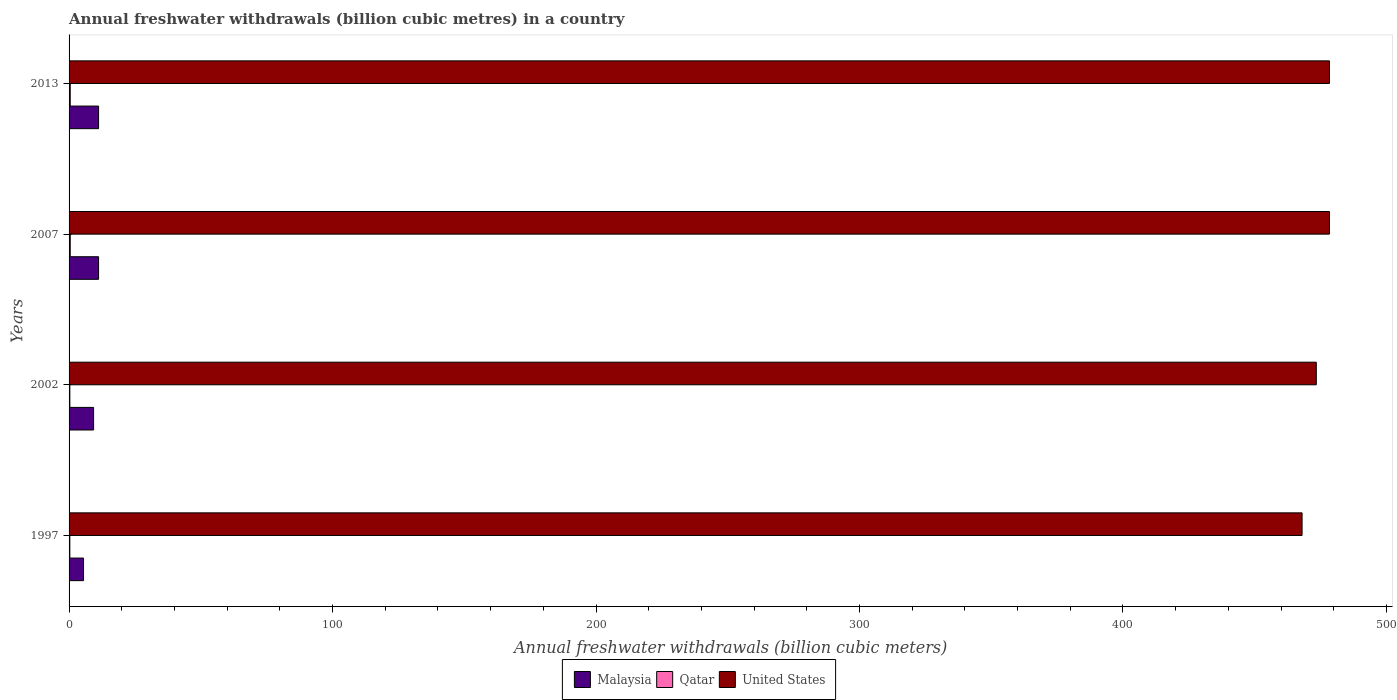How many groups of bars are there?
Offer a terse response. 4. Are the number of bars on each tick of the Y-axis equal?
Give a very brief answer. Yes. How many bars are there on the 4th tick from the top?
Provide a short and direct response. 3. In how many cases, is the number of bars for a given year not equal to the number of legend labels?
Make the answer very short. 0. Across all years, what is the minimum annual freshwater withdrawals in Malaysia?
Provide a succinct answer. 5.49. In which year was the annual freshwater withdrawals in Qatar minimum?
Make the answer very short. 1997. What is the total annual freshwater withdrawals in Qatar in the graph?
Your answer should be very brief. 1.47. What is the difference between the annual freshwater withdrawals in United States in 1997 and that in 2013?
Offer a very short reply. -10.4. What is the difference between the annual freshwater withdrawals in United States in 2007 and the annual freshwater withdrawals in Malaysia in 2002?
Keep it short and to the point. 469.09. What is the average annual freshwater withdrawals in Qatar per year?
Your answer should be compact. 0.37. In the year 2002, what is the difference between the annual freshwater withdrawals in Qatar and annual freshwater withdrawals in United States?
Keep it short and to the point. -473.11. In how many years, is the annual freshwater withdrawals in Malaysia greater than 200 billion cubic meters?
Give a very brief answer. 0. What is the ratio of the annual freshwater withdrawals in Qatar in 2002 to that in 2007?
Keep it short and to the point. 0.66. Is the annual freshwater withdrawals in Qatar in 1997 less than that in 2007?
Your response must be concise. Yes. What is the difference between the highest and the lowest annual freshwater withdrawals in Malaysia?
Offer a terse response. 5.71. In how many years, is the annual freshwater withdrawals in Malaysia greater than the average annual freshwater withdrawals in Malaysia taken over all years?
Offer a very short reply. 3. Is the sum of the annual freshwater withdrawals in United States in 1997 and 2002 greater than the maximum annual freshwater withdrawals in Malaysia across all years?
Provide a succinct answer. Yes. What does the 3rd bar from the top in 1997 represents?
Offer a very short reply. Malaysia. What does the 3rd bar from the bottom in 2013 represents?
Give a very brief answer. United States. How many bars are there?
Provide a succinct answer. 12. Are all the bars in the graph horizontal?
Provide a short and direct response. Yes. What is the difference between two consecutive major ticks on the X-axis?
Offer a terse response. 100. Are the values on the major ticks of X-axis written in scientific E-notation?
Your response must be concise. No. Does the graph contain any zero values?
Keep it short and to the point. No. How are the legend labels stacked?
Provide a short and direct response. Horizontal. What is the title of the graph?
Offer a terse response. Annual freshwater withdrawals (billion cubic metres) in a country. Does "Germany" appear as one of the legend labels in the graph?
Your response must be concise. No. What is the label or title of the X-axis?
Offer a very short reply. Annual freshwater withdrawals (billion cubic meters). What is the label or title of the Y-axis?
Make the answer very short. Years. What is the Annual freshwater withdrawals (billion cubic meters) of Malaysia in 1997?
Your answer should be very brief. 5.49. What is the Annual freshwater withdrawals (billion cubic meters) in Qatar in 1997?
Your answer should be very brief. 0.28. What is the Annual freshwater withdrawals (billion cubic meters) in United States in 1997?
Make the answer very short. 468. What is the Annual freshwater withdrawals (billion cubic meters) in Malaysia in 2002?
Keep it short and to the point. 9.3. What is the Annual freshwater withdrawals (billion cubic meters) in Qatar in 2002?
Offer a terse response. 0.29. What is the Annual freshwater withdrawals (billion cubic meters) in United States in 2002?
Provide a succinct answer. 473.4. What is the Annual freshwater withdrawals (billion cubic meters) in Malaysia in 2007?
Provide a short and direct response. 11.2. What is the Annual freshwater withdrawals (billion cubic meters) in Qatar in 2007?
Your response must be concise. 0.44. What is the Annual freshwater withdrawals (billion cubic meters) in United States in 2007?
Provide a short and direct response. 478.4. What is the Annual freshwater withdrawals (billion cubic meters) of Qatar in 2013?
Keep it short and to the point. 0.44. What is the Annual freshwater withdrawals (billion cubic meters) in United States in 2013?
Offer a terse response. 478.4. Across all years, what is the maximum Annual freshwater withdrawals (billion cubic meters) in Malaysia?
Keep it short and to the point. 11.2. Across all years, what is the maximum Annual freshwater withdrawals (billion cubic meters) of Qatar?
Your answer should be compact. 0.44. Across all years, what is the maximum Annual freshwater withdrawals (billion cubic meters) of United States?
Your answer should be compact. 478.4. Across all years, what is the minimum Annual freshwater withdrawals (billion cubic meters) in Malaysia?
Provide a succinct answer. 5.49. Across all years, what is the minimum Annual freshwater withdrawals (billion cubic meters) in Qatar?
Provide a succinct answer. 0.28. Across all years, what is the minimum Annual freshwater withdrawals (billion cubic meters) of United States?
Keep it short and to the point. 468. What is the total Annual freshwater withdrawals (billion cubic meters) in Malaysia in the graph?
Provide a short and direct response. 37.19. What is the total Annual freshwater withdrawals (billion cubic meters) of Qatar in the graph?
Offer a terse response. 1.47. What is the total Annual freshwater withdrawals (billion cubic meters) of United States in the graph?
Keep it short and to the point. 1898.2. What is the difference between the Annual freshwater withdrawals (billion cubic meters) in Malaysia in 1997 and that in 2002?
Provide a short and direct response. -3.82. What is the difference between the Annual freshwater withdrawals (billion cubic meters) in Qatar in 1997 and that in 2002?
Make the answer very short. -0.01. What is the difference between the Annual freshwater withdrawals (billion cubic meters) in Malaysia in 1997 and that in 2007?
Give a very brief answer. -5.71. What is the difference between the Annual freshwater withdrawals (billion cubic meters) in Qatar in 1997 and that in 2007?
Provide a short and direct response. -0.16. What is the difference between the Annual freshwater withdrawals (billion cubic meters) of Malaysia in 1997 and that in 2013?
Offer a terse response. -5.71. What is the difference between the Annual freshwater withdrawals (billion cubic meters) of Qatar in 1997 and that in 2013?
Make the answer very short. -0.16. What is the difference between the Annual freshwater withdrawals (billion cubic meters) of United States in 1997 and that in 2013?
Your response must be concise. -10.4. What is the difference between the Annual freshwater withdrawals (billion cubic meters) of Malaysia in 2002 and that in 2007?
Make the answer very short. -1.9. What is the difference between the Annual freshwater withdrawals (billion cubic meters) in Qatar in 2002 and that in 2007?
Make the answer very short. -0.15. What is the difference between the Annual freshwater withdrawals (billion cubic meters) of United States in 2002 and that in 2007?
Offer a terse response. -5. What is the difference between the Annual freshwater withdrawals (billion cubic meters) of Malaysia in 2002 and that in 2013?
Provide a succinct answer. -1.9. What is the difference between the Annual freshwater withdrawals (billion cubic meters) in Qatar in 2002 and that in 2013?
Ensure brevity in your answer.  -0.15. What is the difference between the Annual freshwater withdrawals (billion cubic meters) of Malaysia in 1997 and the Annual freshwater withdrawals (billion cubic meters) of Qatar in 2002?
Your response must be concise. 5.19. What is the difference between the Annual freshwater withdrawals (billion cubic meters) in Malaysia in 1997 and the Annual freshwater withdrawals (billion cubic meters) in United States in 2002?
Provide a succinct answer. -467.91. What is the difference between the Annual freshwater withdrawals (billion cubic meters) of Qatar in 1997 and the Annual freshwater withdrawals (billion cubic meters) of United States in 2002?
Provide a short and direct response. -473.12. What is the difference between the Annual freshwater withdrawals (billion cubic meters) in Malaysia in 1997 and the Annual freshwater withdrawals (billion cubic meters) in Qatar in 2007?
Ensure brevity in your answer.  5.04. What is the difference between the Annual freshwater withdrawals (billion cubic meters) in Malaysia in 1997 and the Annual freshwater withdrawals (billion cubic meters) in United States in 2007?
Offer a very short reply. -472.91. What is the difference between the Annual freshwater withdrawals (billion cubic meters) of Qatar in 1997 and the Annual freshwater withdrawals (billion cubic meters) of United States in 2007?
Your response must be concise. -478.12. What is the difference between the Annual freshwater withdrawals (billion cubic meters) of Malaysia in 1997 and the Annual freshwater withdrawals (billion cubic meters) of Qatar in 2013?
Give a very brief answer. 5.04. What is the difference between the Annual freshwater withdrawals (billion cubic meters) in Malaysia in 1997 and the Annual freshwater withdrawals (billion cubic meters) in United States in 2013?
Your answer should be compact. -472.91. What is the difference between the Annual freshwater withdrawals (billion cubic meters) in Qatar in 1997 and the Annual freshwater withdrawals (billion cubic meters) in United States in 2013?
Your answer should be compact. -478.12. What is the difference between the Annual freshwater withdrawals (billion cubic meters) in Malaysia in 2002 and the Annual freshwater withdrawals (billion cubic meters) in Qatar in 2007?
Offer a terse response. 8.86. What is the difference between the Annual freshwater withdrawals (billion cubic meters) of Malaysia in 2002 and the Annual freshwater withdrawals (billion cubic meters) of United States in 2007?
Your answer should be compact. -469.1. What is the difference between the Annual freshwater withdrawals (billion cubic meters) of Qatar in 2002 and the Annual freshwater withdrawals (billion cubic meters) of United States in 2007?
Your answer should be compact. -478.11. What is the difference between the Annual freshwater withdrawals (billion cubic meters) of Malaysia in 2002 and the Annual freshwater withdrawals (billion cubic meters) of Qatar in 2013?
Offer a terse response. 8.86. What is the difference between the Annual freshwater withdrawals (billion cubic meters) of Malaysia in 2002 and the Annual freshwater withdrawals (billion cubic meters) of United States in 2013?
Offer a very short reply. -469.1. What is the difference between the Annual freshwater withdrawals (billion cubic meters) of Qatar in 2002 and the Annual freshwater withdrawals (billion cubic meters) of United States in 2013?
Make the answer very short. -478.11. What is the difference between the Annual freshwater withdrawals (billion cubic meters) of Malaysia in 2007 and the Annual freshwater withdrawals (billion cubic meters) of Qatar in 2013?
Offer a terse response. 10.76. What is the difference between the Annual freshwater withdrawals (billion cubic meters) of Malaysia in 2007 and the Annual freshwater withdrawals (billion cubic meters) of United States in 2013?
Your response must be concise. -467.2. What is the difference between the Annual freshwater withdrawals (billion cubic meters) in Qatar in 2007 and the Annual freshwater withdrawals (billion cubic meters) in United States in 2013?
Give a very brief answer. -477.96. What is the average Annual freshwater withdrawals (billion cubic meters) in Malaysia per year?
Provide a short and direct response. 9.3. What is the average Annual freshwater withdrawals (billion cubic meters) in Qatar per year?
Ensure brevity in your answer.  0.37. What is the average Annual freshwater withdrawals (billion cubic meters) in United States per year?
Give a very brief answer. 474.55. In the year 1997, what is the difference between the Annual freshwater withdrawals (billion cubic meters) of Malaysia and Annual freshwater withdrawals (billion cubic meters) of Qatar?
Your answer should be compact. 5.2. In the year 1997, what is the difference between the Annual freshwater withdrawals (billion cubic meters) in Malaysia and Annual freshwater withdrawals (billion cubic meters) in United States?
Your answer should be compact. -462.51. In the year 1997, what is the difference between the Annual freshwater withdrawals (billion cubic meters) of Qatar and Annual freshwater withdrawals (billion cubic meters) of United States?
Keep it short and to the point. -467.72. In the year 2002, what is the difference between the Annual freshwater withdrawals (billion cubic meters) of Malaysia and Annual freshwater withdrawals (billion cubic meters) of Qatar?
Provide a succinct answer. 9.01. In the year 2002, what is the difference between the Annual freshwater withdrawals (billion cubic meters) in Malaysia and Annual freshwater withdrawals (billion cubic meters) in United States?
Keep it short and to the point. -464.1. In the year 2002, what is the difference between the Annual freshwater withdrawals (billion cubic meters) in Qatar and Annual freshwater withdrawals (billion cubic meters) in United States?
Provide a short and direct response. -473.11. In the year 2007, what is the difference between the Annual freshwater withdrawals (billion cubic meters) of Malaysia and Annual freshwater withdrawals (billion cubic meters) of Qatar?
Provide a short and direct response. 10.76. In the year 2007, what is the difference between the Annual freshwater withdrawals (billion cubic meters) in Malaysia and Annual freshwater withdrawals (billion cubic meters) in United States?
Offer a terse response. -467.2. In the year 2007, what is the difference between the Annual freshwater withdrawals (billion cubic meters) in Qatar and Annual freshwater withdrawals (billion cubic meters) in United States?
Provide a succinct answer. -477.96. In the year 2013, what is the difference between the Annual freshwater withdrawals (billion cubic meters) of Malaysia and Annual freshwater withdrawals (billion cubic meters) of Qatar?
Your response must be concise. 10.76. In the year 2013, what is the difference between the Annual freshwater withdrawals (billion cubic meters) in Malaysia and Annual freshwater withdrawals (billion cubic meters) in United States?
Your response must be concise. -467.2. In the year 2013, what is the difference between the Annual freshwater withdrawals (billion cubic meters) of Qatar and Annual freshwater withdrawals (billion cubic meters) of United States?
Give a very brief answer. -477.96. What is the ratio of the Annual freshwater withdrawals (billion cubic meters) of Malaysia in 1997 to that in 2002?
Provide a succinct answer. 0.59. What is the ratio of the Annual freshwater withdrawals (billion cubic meters) in Qatar in 1997 to that in 2002?
Give a very brief answer. 0.97. What is the ratio of the Annual freshwater withdrawals (billion cubic meters) of Malaysia in 1997 to that in 2007?
Provide a succinct answer. 0.49. What is the ratio of the Annual freshwater withdrawals (billion cubic meters) in Qatar in 1997 to that in 2007?
Keep it short and to the point. 0.64. What is the ratio of the Annual freshwater withdrawals (billion cubic meters) in United States in 1997 to that in 2007?
Your answer should be very brief. 0.98. What is the ratio of the Annual freshwater withdrawals (billion cubic meters) of Malaysia in 1997 to that in 2013?
Offer a very short reply. 0.49. What is the ratio of the Annual freshwater withdrawals (billion cubic meters) of Qatar in 1997 to that in 2013?
Make the answer very short. 0.64. What is the ratio of the Annual freshwater withdrawals (billion cubic meters) of United States in 1997 to that in 2013?
Your answer should be compact. 0.98. What is the ratio of the Annual freshwater withdrawals (billion cubic meters) in Malaysia in 2002 to that in 2007?
Keep it short and to the point. 0.83. What is the ratio of the Annual freshwater withdrawals (billion cubic meters) of Qatar in 2002 to that in 2007?
Your answer should be very brief. 0.66. What is the ratio of the Annual freshwater withdrawals (billion cubic meters) in United States in 2002 to that in 2007?
Your answer should be compact. 0.99. What is the ratio of the Annual freshwater withdrawals (billion cubic meters) of Malaysia in 2002 to that in 2013?
Offer a terse response. 0.83. What is the ratio of the Annual freshwater withdrawals (billion cubic meters) in Qatar in 2002 to that in 2013?
Provide a succinct answer. 0.66. What is the ratio of the Annual freshwater withdrawals (billion cubic meters) of United States in 2002 to that in 2013?
Your answer should be compact. 0.99. What is the ratio of the Annual freshwater withdrawals (billion cubic meters) of Malaysia in 2007 to that in 2013?
Offer a terse response. 1. What is the ratio of the Annual freshwater withdrawals (billion cubic meters) of Qatar in 2007 to that in 2013?
Keep it short and to the point. 1. What is the difference between the highest and the second highest Annual freshwater withdrawals (billion cubic meters) of United States?
Offer a very short reply. 0. What is the difference between the highest and the lowest Annual freshwater withdrawals (billion cubic meters) in Malaysia?
Provide a short and direct response. 5.71. What is the difference between the highest and the lowest Annual freshwater withdrawals (billion cubic meters) of Qatar?
Your answer should be compact. 0.16. What is the difference between the highest and the lowest Annual freshwater withdrawals (billion cubic meters) of United States?
Offer a very short reply. 10.4. 